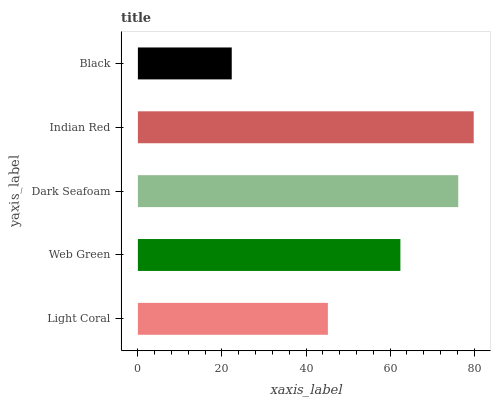Is Black the minimum?
Answer yes or no. Yes. Is Indian Red the maximum?
Answer yes or no. Yes. Is Web Green the minimum?
Answer yes or no. No. Is Web Green the maximum?
Answer yes or no. No. Is Web Green greater than Light Coral?
Answer yes or no. Yes. Is Light Coral less than Web Green?
Answer yes or no. Yes. Is Light Coral greater than Web Green?
Answer yes or no. No. Is Web Green less than Light Coral?
Answer yes or no. No. Is Web Green the high median?
Answer yes or no. Yes. Is Web Green the low median?
Answer yes or no. Yes. Is Light Coral the high median?
Answer yes or no. No. Is Dark Seafoam the low median?
Answer yes or no. No. 